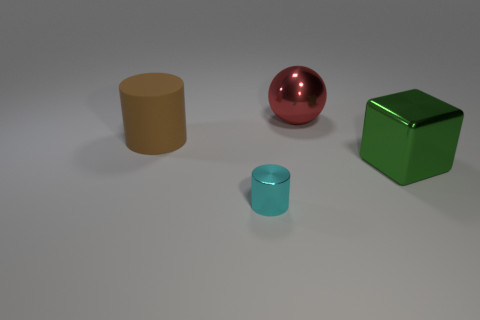Subtract all yellow cylinders. Subtract all blue spheres. How many cylinders are left? 2 Add 2 rubber objects. How many objects exist? 6 Subtract all cubes. How many objects are left? 3 Add 2 large rubber cylinders. How many large rubber cylinders are left? 3 Add 1 tiny gray matte objects. How many tiny gray matte objects exist? 1 Subtract 1 brown cylinders. How many objects are left? 3 Subtract all small yellow rubber cubes. Subtract all big metal cubes. How many objects are left? 3 